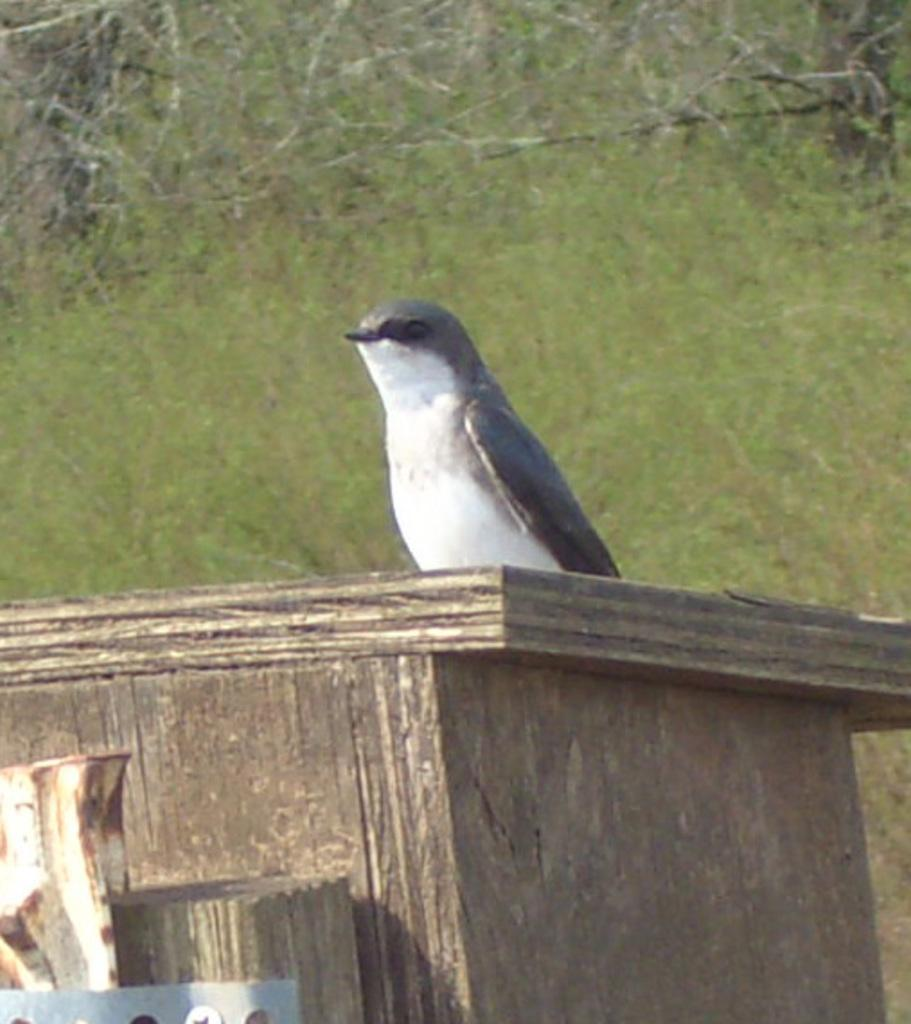What type of animal is in the image? There is a bird in the image. Where is the bird located? The bird is on a wooden box. What colors can be seen on the bird? The bird has white and grey coloring. What color is the background of the image? The background of the image is green. What is the bird's profit margin in the image? There is no information about profit margins in the image, as it features a bird on a wooden box with a green background. 